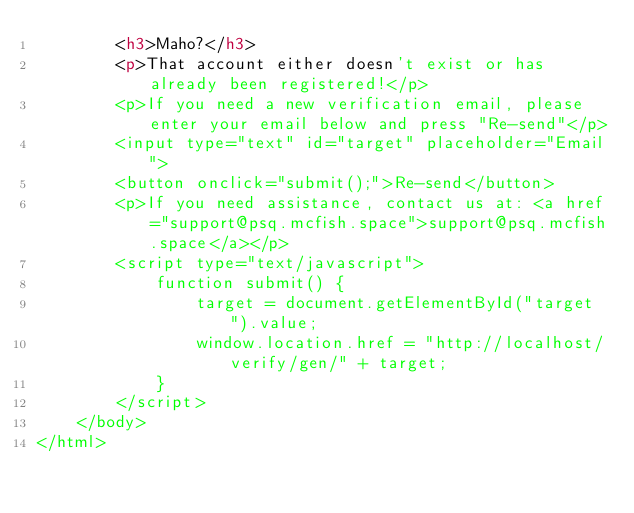Convert code to text. <code><loc_0><loc_0><loc_500><loc_500><_HTML_>        <h3>Maho?</h3>
        <p>That account either doesn't exist or has already been registered!</p>
        <p>If you need a new verification email, please enter your email below and press "Re-send"</p>
        <input type="text" id="target" placeholder="Email">
        <button onclick="submit();">Re-send</button>
        <p>If you need assistance, contact us at: <a href="support@psq.mcfish.space">support@psq.mcfish.space</a></p>
        <script type="text/javascript">
            function submit() {
                target = document.getElementById("target").value;
                window.location.href = "http://localhost/verify/gen/" + target;
            }
        </script>
    </body>
</html>
</code> 